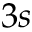Convert formula to latex. <formula><loc_0><loc_0><loc_500><loc_500>3 s</formula> 